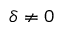<formula> <loc_0><loc_0><loc_500><loc_500>\delta \neq 0</formula> 